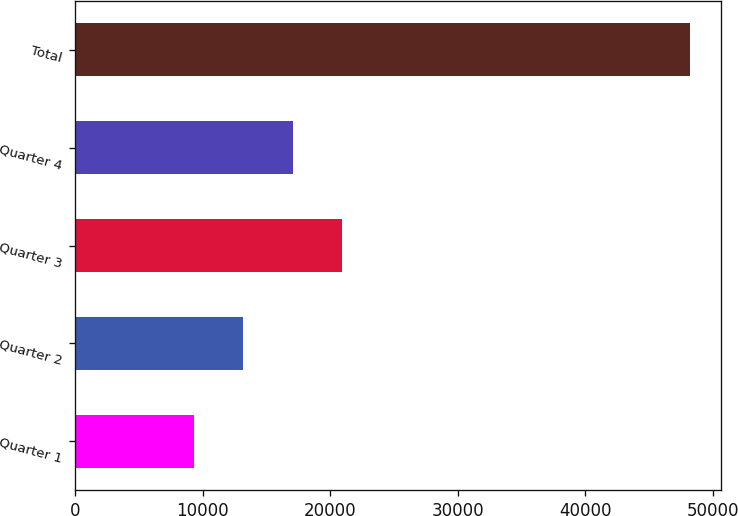Convert chart. <chart><loc_0><loc_0><loc_500><loc_500><bar_chart><fcel>Quarter 1<fcel>Quarter 2<fcel>Quarter 3<fcel>Quarter 4<fcel>Total<nl><fcel>9295<fcel>13186.9<fcel>20970.7<fcel>17078.8<fcel>48214<nl></chart> 